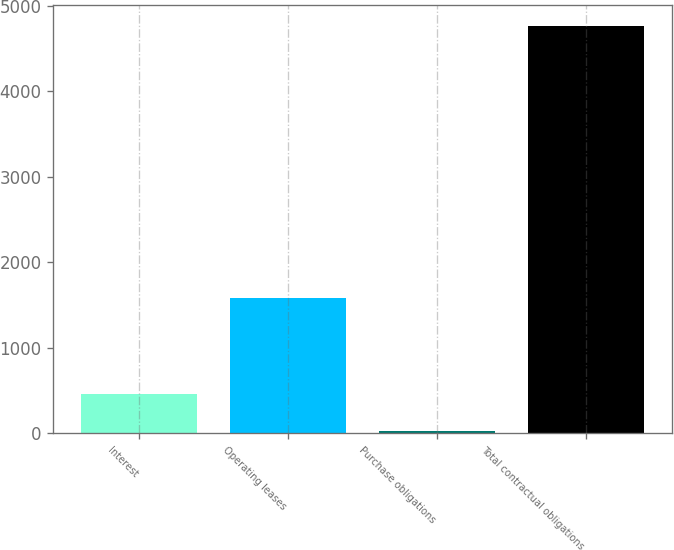<chart> <loc_0><loc_0><loc_500><loc_500><bar_chart><fcel>Interest<fcel>Operating leases<fcel>Purchase obligations<fcel>Total contractual obligations<nl><fcel>458.6<fcel>1580<fcel>28<fcel>4764.6<nl></chart> 